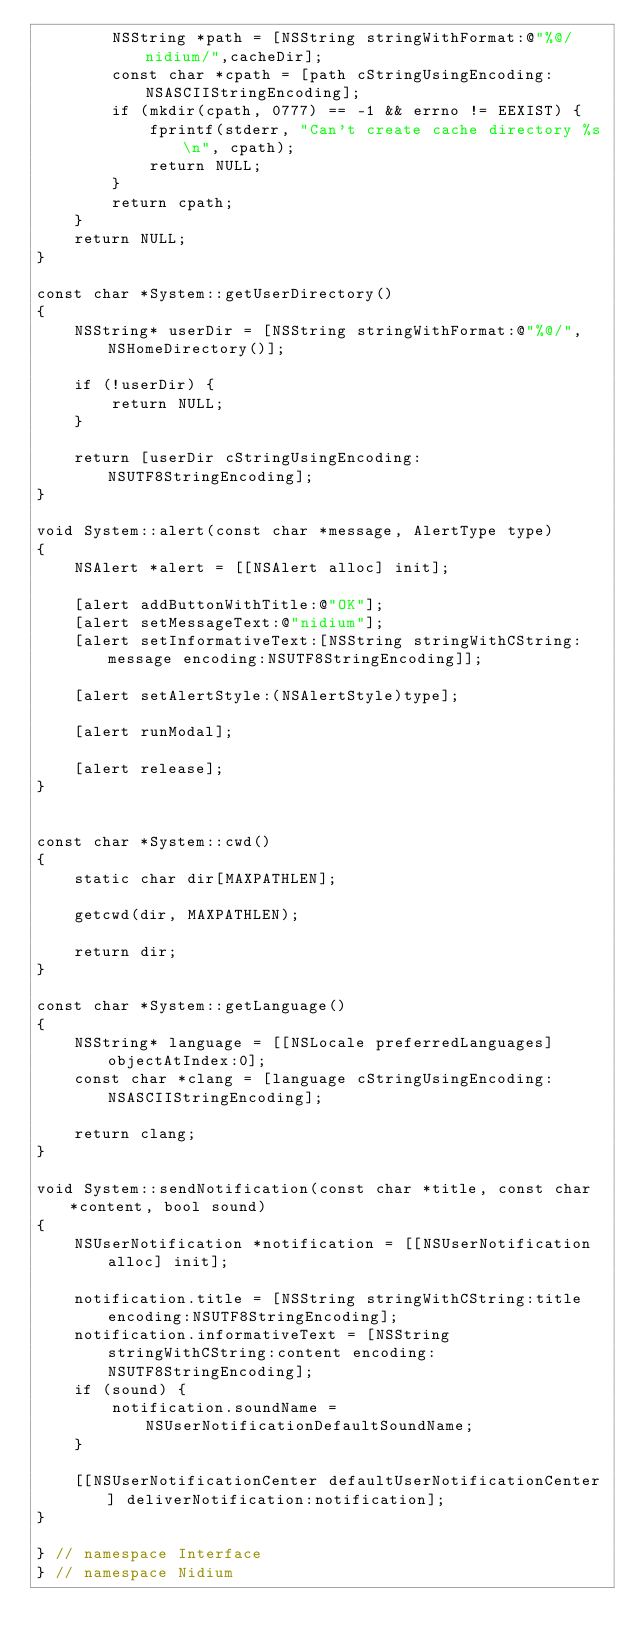Convert code to text. <code><loc_0><loc_0><loc_500><loc_500><_ObjectiveC_>        NSString *path = [NSString stringWithFormat:@"%@/nidium/",cacheDir];
        const char *cpath = [path cStringUsingEncoding:NSASCIIStringEncoding];
        if (mkdir(cpath, 0777) == -1 && errno != EEXIST) {
            fprintf(stderr, "Can't create cache directory %s\n", cpath);
            return NULL;
        }
        return cpath;
    }
    return NULL;
}

const char *System::getUserDirectory()
{
    NSString* userDir = [NSString stringWithFormat:@"%@/", NSHomeDirectory()];

    if (!userDir) {
        return NULL;
    }

    return [userDir cStringUsingEncoding:NSUTF8StringEncoding];
}

void System::alert(const char *message, AlertType type)
{
    NSAlert *alert = [[NSAlert alloc] init];

    [alert addButtonWithTitle:@"OK"];
    [alert setMessageText:@"nidium"];
    [alert setInformativeText:[NSString stringWithCString:message encoding:NSUTF8StringEncoding]];

    [alert setAlertStyle:(NSAlertStyle)type];

    [alert runModal];

    [alert release];
}


const char *System::cwd()
{
    static char dir[MAXPATHLEN];

    getcwd(dir, MAXPATHLEN);

    return dir;
}

const char *System::getLanguage()
{
    NSString* language = [[NSLocale preferredLanguages] objectAtIndex:0];
    const char *clang = [language cStringUsingEncoding:NSASCIIStringEncoding];

    return clang;
}

void System::sendNotification(const char *title, const char *content, bool sound)
{
    NSUserNotification *notification = [[NSUserNotification alloc] init];

    notification.title = [NSString stringWithCString:title encoding:NSUTF8StringEncoding];
    notification.informativeText = [NSString stringWithCString:content encoding:NSUTF8StringEncoding];
    if (sound) {
        notification.soundName = NSUserNotificationDefaultSoundName;
    }

    [[NSUserNotificationCenter defaultUserNotificationCenter] deliverNotification:notification];
}

} // namespace Interface
} // namespace Nidium

</code> 